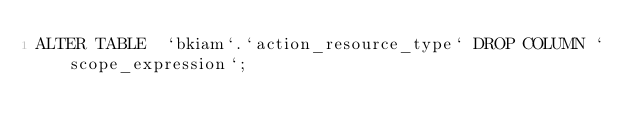<code> <loc_0><loc_0><loc_500><loc_500><_SQL_>ALTER TABLE  `bkiam`.`action_resource_type` DROP COLUMN `scope_expression`;
</code> 